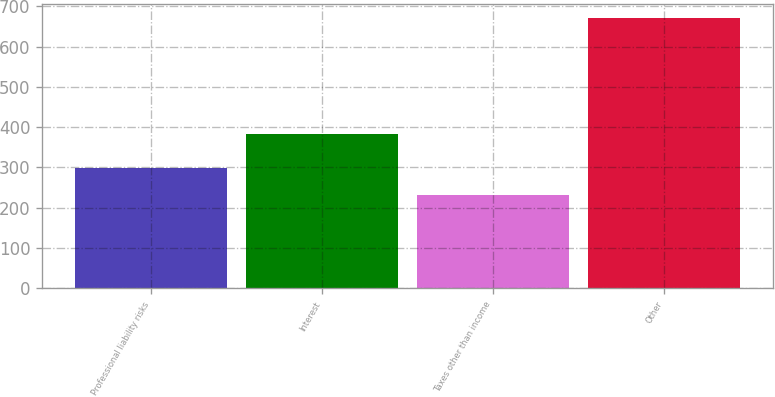Convert chart to OTSL. <chart><loc_0><loc_0><loc_500><loc_500><bar_chart><fcel>Professional liability risks<fcel>Interest<fcel>Taxes other than income<fcel>Other<nl><fcel>298<fcel>383<fcel>232<fcel>672<nl></chart> 